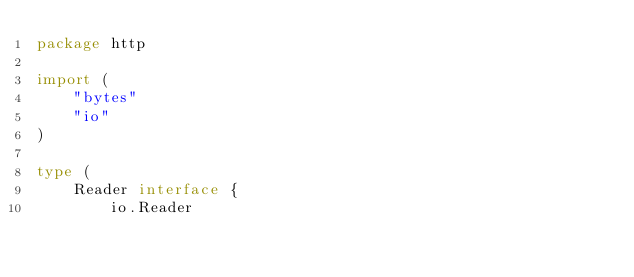<code> <loc_0><loc_0><loc_500><loc_500><_Go_>package http

import (
	"bytes"
	"io"
)

type (
	Reader interface {
		io.Reader</code> 